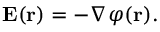<formula> <loc_0><loc_0><loc_500><loc_500>E ( r ) = - \nabla \varphi ( r ) .</formula> 